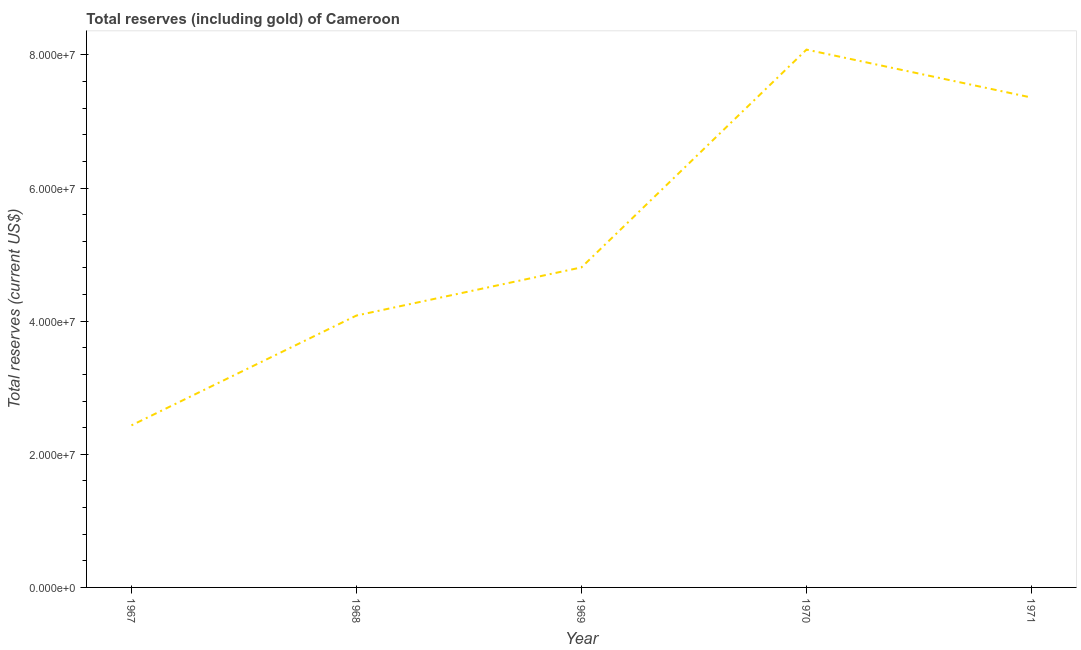What is the total reserves (including gold) in 1970?
Keep it short and to the point. 8.08e+07. Across all years, what is the maximum total reserves (including gold)?
Your answer should be very brief. 8.08e+07. Across all years, what is the minimum total reserves (including gold)?
Ensure brevity in your answer.  2.43e+07. In which year was the total reserves (including gold) maximum?
Provide a short and direct response. 1970. In which year was the total reserves (including gold) minimum?
Ensure brevity in your answer.  1967. What is the sum of the total reserves (including gold)?
Provide a short and direct response. 2.68e+08. What is the difference between the total reserves (including gold) in 1967 and 1971?
Keep it short and to the point. -4.93e+07. What is the average total reserves (including gold) per year?
Ensure brevity in your answer.  5.35e+07. What is the median total reserves (including gold)?
Give a very brief answer. 4.81e+07. Do a majority of the years between 1971 and 1970 (inclusive) have total reserves (including gold) greater than 76000000 US$?
Ensure brevity in your answer.  No. What is the ratio of the total reserves (including gold) in 1968 to that in 1970?
Your response must be concise. 0.51. Is the difference between the total reserves (including gold) in 1969 and 1970 greater than the difference between any two years?
Ensure brevity in your answer.  No. What is the difference between the highest and the second highest total reserves (including gold)?
Your answer should be compact. 7.20e+06. What is the difference between the highest and the lowest total reserves (including gold)?
Your response must be concise. 5.65e+07. In how many years, is the total reserves (including gold) greater than the average total reserves (including gold) taken over all years?
Ensure brevity in your answer.  2. How many lines are there?
Offer a very short reply. 1. How many years are there in the graph?
Your answer should be very brief. 5. Does the graph contain any zero values?
Keep it short and to the point. No. What is the title of the graph?
Provide a succinct answer. Total reserves (including gold) of Cameroon. What is the label or title of the X-axis?
Your response must be concise. Year. What is the label or title of the Y-axis?
Your answer should be compact. Total reserves (current US$). What is the Total reserves (current US$) in 1967?
Ensure brevity in your answer.  2.43e+07. What is the Total reserves (current US$) of 1968?
Ensure brevity in your answer.  4.09e+07. What is the Total reserves (current US$) in 1969?
Provide a short and direct response. 4.81e+07. What is the Total reserves (current US$) in 1970?
Offer a terse response. 8.08e+07. What is the Total reserves (current US$) of 1971?
Provide a short and direct response. 7.36e+07. What is the difference between the Total reserves (current US$) in 1967 and 1968?
Your answer should be very brief. -1.65e+07. What is the difference between the Total reserves (current US$) in 1967 and 1969?
Provide a short and direct response. -2.37e+07. What is the difference between the Total reserves (current US$) in 1967 and 1970?
Offer a terse response. -5.65e+07. What is the difference between the Total reserves (current US$) in 1967 and 1971?
Offer a terse response. -4.93e+07. What is the difference between the Total reserves (current US$) in 1968 and 1969?
Your answer should be very brief. -7.23e+06. What is the difference between the Total reserves (current US$) in 1968 and 1970?
Offer a very short reply. -4.00e+07. What is the difference between the Total reserves (current US$) in 1968 and 1971?
Your answer should be very brief. -3.28e+07. What is the difference between the Total reserves (current US$) in 1969 and 1970?
Offer a very short reply. -3.27e+07. What is the difference between the Total reserves (current US$) in 1969 and 1971?
Make the answer very short. -2.55e+07. What is the difference between the Total reserves (current US$) in 1970 and 1971?
Provide a succinct answer. 7.20e+06. What is the ratio of the Total reserves (current US$) in 1967 to that in 1968?
Your response must be concise. 0.6. What is the ratio of the Total reserves (current US$) in 1967 to that in 1969?
Offer a terse response. 0.51. What is the ratio of the Total reserves (current US$) in 1967 to that in 1970?
Give a very brief answer. 0.3. What is the ratio of the Total reserves (current US$) in 1967 to that in 1971?
Keep it short and to the point. 0.33. What is the ratio of the Total reserves (current US$) in 1968 to that in 1969?
Offer a terse response. 0.85. What is the ratio of the Total reserves (current US$) in 1968 to that in 1970?
Make the answer very short. 0.51. What is the ratio of the Total reserves (current US$) in 1968 to that in 1971?
Your answer should be compact. 0.56. What is the ratio of the Total reserves (current US$) in 1969 to that in 1970?
Keep it short and to the point. 0.59. What is the ratio of the Total reserves (current US$) in 1969 to that in 1971?
Provide a short and direct response. 0.65. What is the ratio of the Total reserves (current US$) in 1970 to that in 1971?
Offer a very short reply. 1.1. 